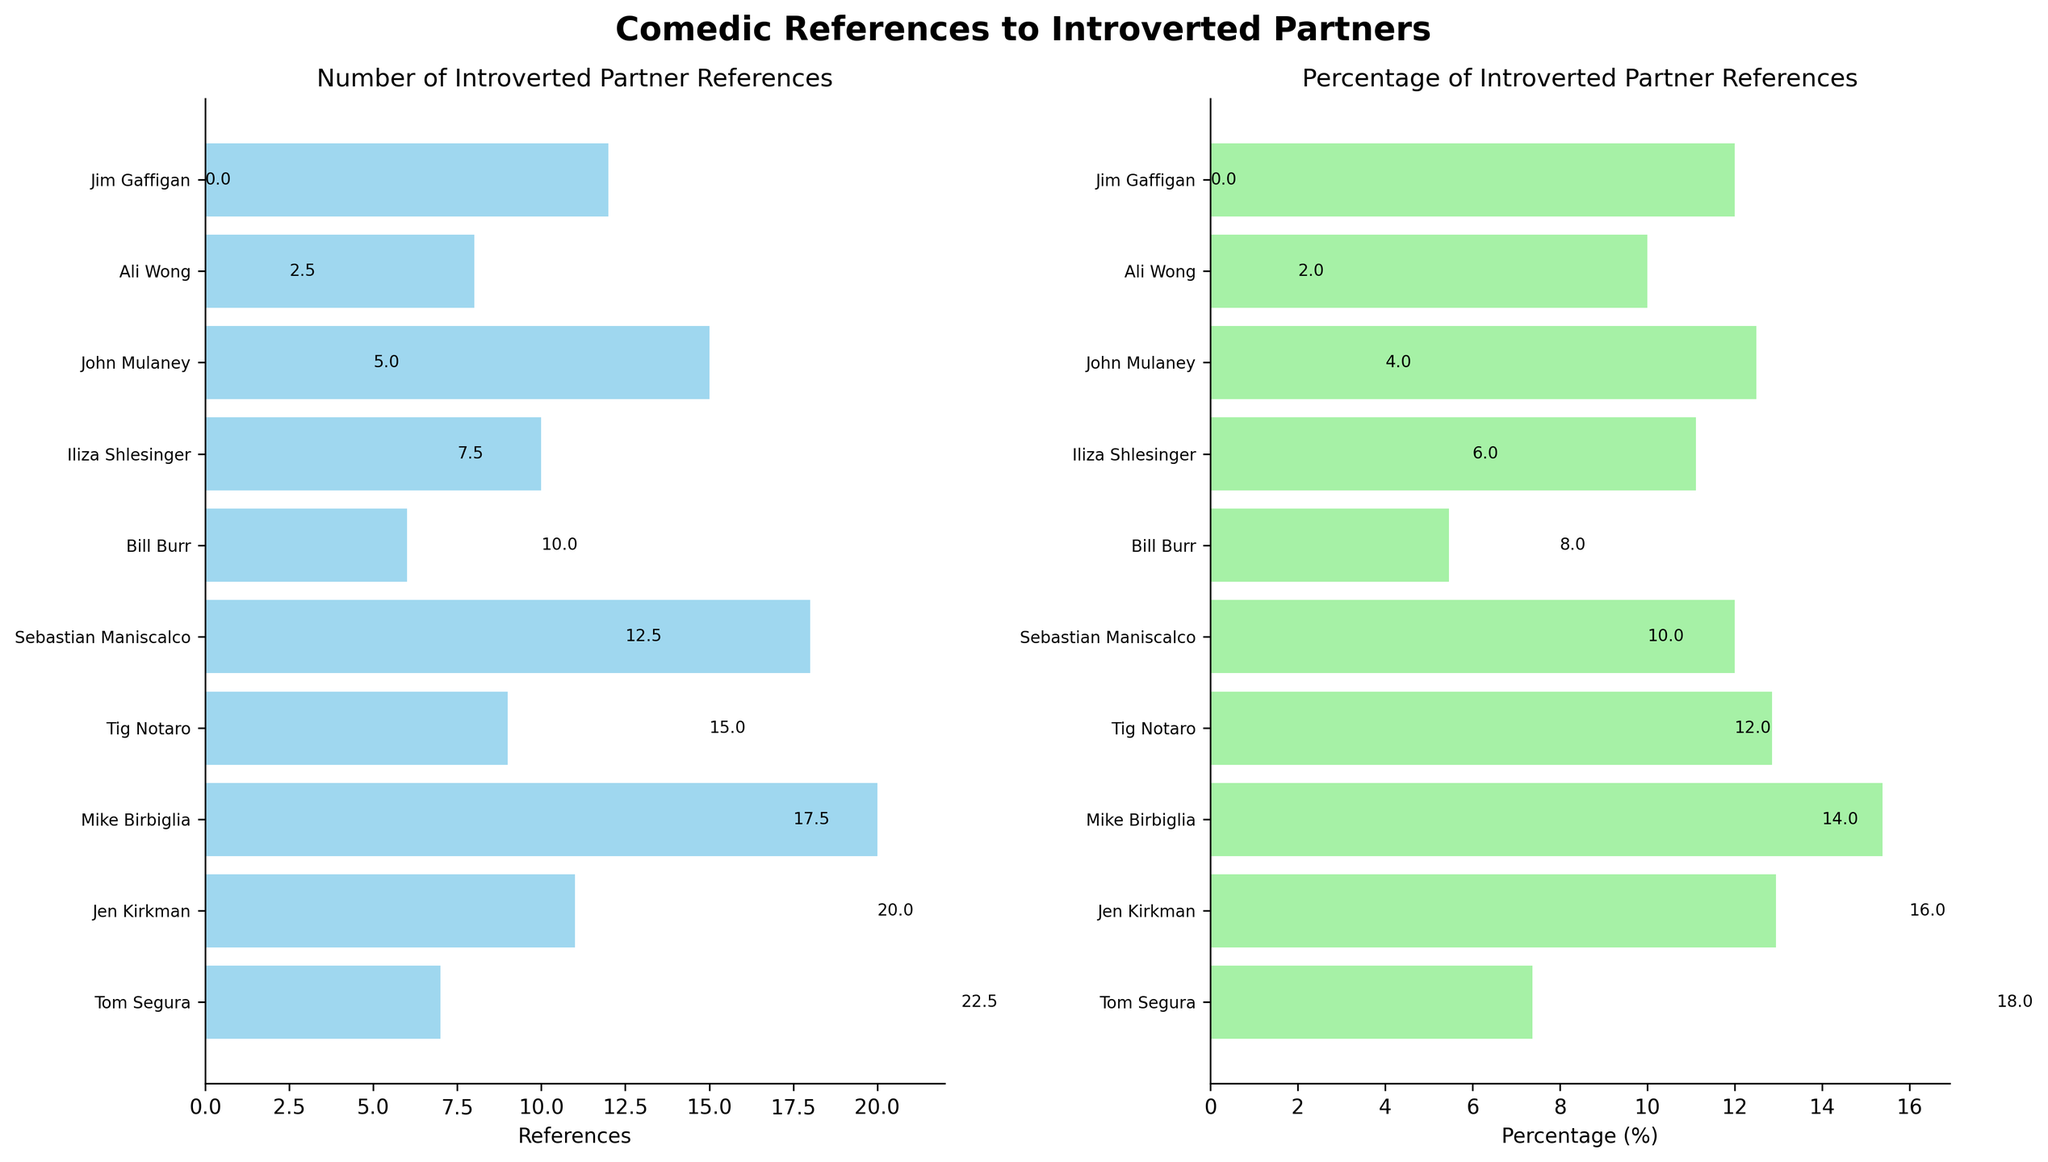How many introverted partner references does Jim Gaffigan have? Look at the first subplot and find the bar labeled "Jim Gaffigan"; the value is shown at the end of the bar.
Answer: 12 Which comedian has the highest number of introverted partner references? In the first subplot, identify the bar with the longest length; the top bar corresponds to the comedian with the highest references.
Answer: Mike Birbiglia What is the title of the overall figure? The figure title is at the top, centered in bold.
Answer: Comedic References to Introverted Partners Who has a higher percentage of introverted partner references, Iliza Shlesinger or Tom Segura? Look at the percentage values in the second subplot and compare the lengths of the bars for Iliza Shlesinger and Tom Segura.
Answer: Iliza Shlesinger What is the total number of jokes made by Bill Burr? The figure does not show the total number of jokes directly; this information is in the provided data.
Answer: 110 Which comedian has the lowest percentage of introverted partner references? In the second subplot, find the bar with the shortest length and identify the comedian.
Answer: Bill Burr Calculate the average number of introverted partner references across all comedians. Sum all the reference values from the first subplot (12 + 8 + 15 + 10 + 6 + 18 + 9 + 20 + 11 + 7) and divide by the number of comedians (10). The average reference is (116 / 10 = 11.6).
Answer: 11.6 Compare the number of introverted partner references between John Mulaney and Tig Notaro. How many more references does John Mulaney have? Find the bars for John Mulaney and Tig Notaro in the first subplot; subtract Tig Notaro's references from John Mulaney's.
Answer: 6 What percentage of total jokes are focused on introverted partners by Mike Birbiglia? Use the second subplot to identify the bar for Mike Birbiglia and read the percentage value.
Answer: 15.4 How does the bar color differ between the two subplots? Note the colors used for the bars in each subplot; the first uses skyblue, and the second uses lightgreen.
Answer: Skyblue and Lightgreen 